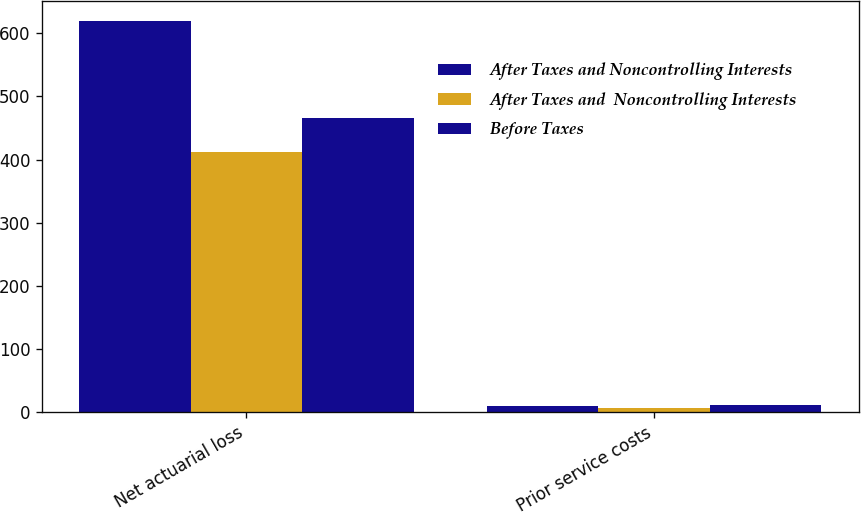<chart> <loc_0><loc_0><loc_500><loc_500><stacked_bar_chart><ecel><fcel>Net actuarial loss<fcel>Prior service costs<nl><fcel>After Taxes and Noncontrolling Interests<fcel>620<fcel>10<nl><fcel>After Taxes and  Noncontrolling Interests<fcel>412<fcel>6<nl><fcel>Before Taxes<fcel>466<fcel>11<nl></chart> 